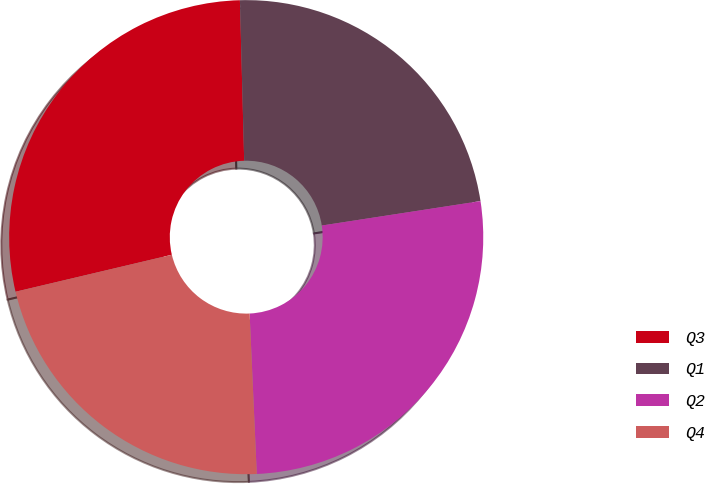<chart> <loc_0><loc_0><loc_500><loc_500><pie_chart><fcel>Q3<fcel>Q1<fcel>Q2<fcel>Q4<nl><fcel>28.27%<fcel>22.99%<fcel>26.72%<fcel>22.01%<nl></chart> 